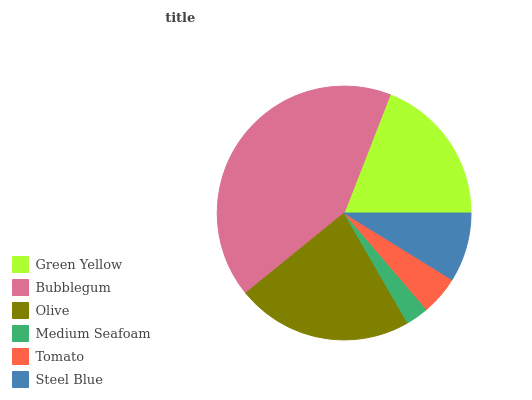Is Medium Seafoam the minimum?
Answer yes or no. Yes. Is Bubblegum the maximum?
Answer yes or no. Yes. Is Olive the minimum?
Answer yes or no. No. Is Olive the maximum?
Answer yes or no. No. Is Bubblegum greater than Olive?
Answer yes or no. Yes. Is Olive less than Bubblegum?
Answer yes or no. Yes. Is Olive greater than Bubblegum?
Answer yes or no. No. Is Bubblegum less than Olive?
Answer yes or no. No. Is Green Yellow the high median?
Answer yes or no. Yes. Is Steel Blue the low median?
Answer yes or no. Yes. Is Olive the high median?
Answer yes or no. No. Is Green Yellow the low median?
Answer yes or no. No. 